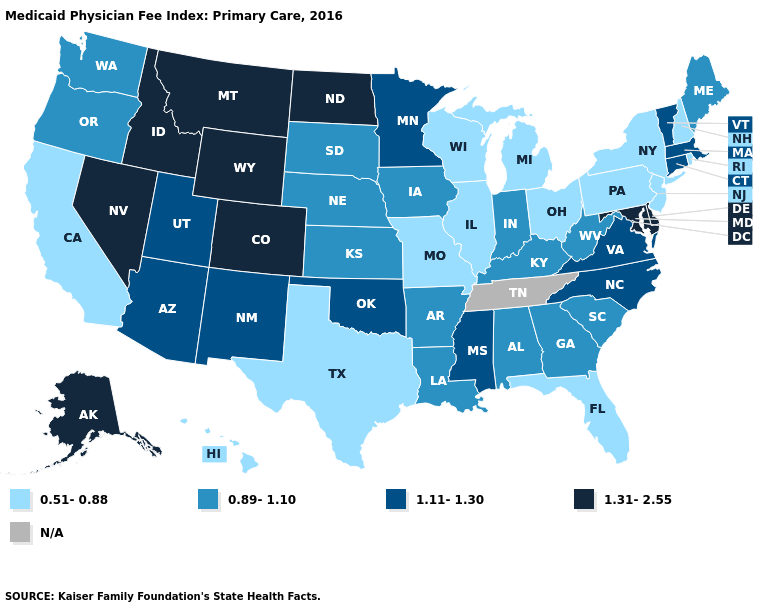What is the value of South Carolina?
Answer briefly. 0.89-1.10. Which states have the lowest value in the West?
Give a very brief answer. California, Hawaii. Among the states that border Pennsylvania , which have the lowest value?
Short answer required. New Jersey, New York, Ohio. Which states have the highest value in the USA?
Give a very brief answer. Alaska, Colorado, Delaware, Idaho, Maryland, Montana, Nevada, North Dakota, Wyoming. What is the value of Maine?
Be succinct. 0.89-1.10. Which states hav the highest value in the South?
Answer briefly. Delaware, Maryland. What is the value of Missouri?
Give a very brief answer. 0.51-0.88. What is the lowest value in the USA?
Keep it brief. 0.51-0.88. What is the lowest value in the USA?
Answer briefly. 0.51-0.88. What is the lowest value in states that border Georgia?
Write a very short answer. 0.51-0.88. Name the states that have a value in the range 1.31-2.55?
Quick response, please. Alaska, Colorado, Delaware, Idaho, Maryland, Montana, Nevada, North Dakota, Wyoming. Does Colorado have the lowest value in the USA?
Give a very brief answer. No. 